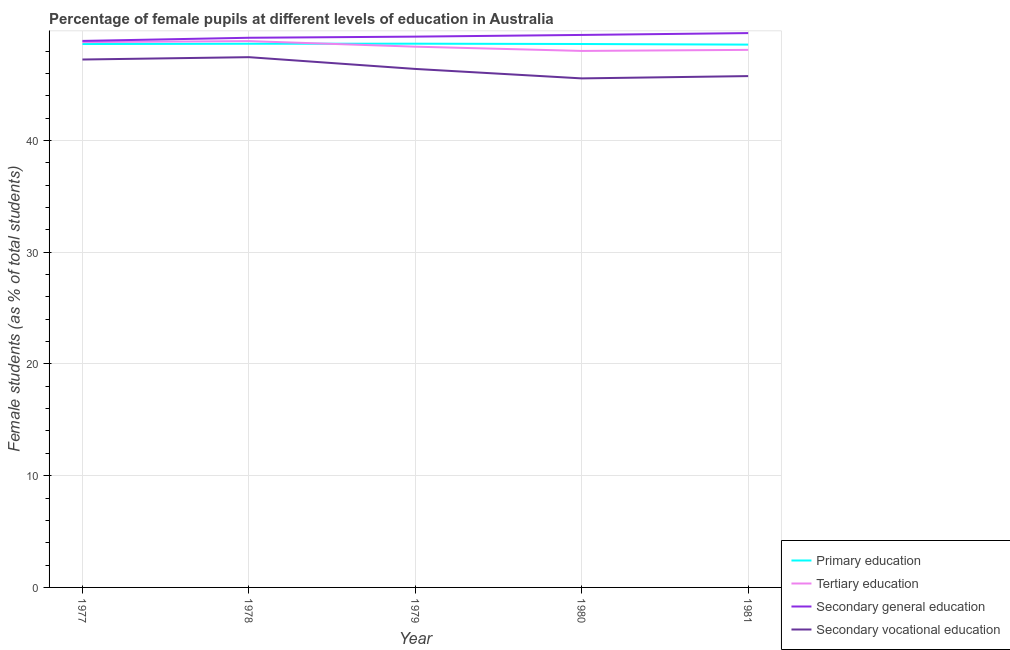Does the line corresponding to percentage of female students in tertiary education intersect with the line corresponding to percentage of female students in secondary education?
Your answer should be very brief. No. What is the percentage of female students in secondary vocational education in 1979?
Offer a terse response. 46.4. Across all years, what is the maximum percentage of female students in secondary education?
Your answer should be very brief. 49.61. Across all years, what is the minimum percentage of female students in secondary education?
Ensure brevity in your answer.  48.91. In which year was the percentage of female students in tertiary education maximum?
Provide a short and direct response. 1978. In which year was the percentage of female students in tertiary education minimum?
Provide a succinct answer. 1980. What is the total percentage of female students in tertiary education in the graph?
Your answer should be compact. 242.19. What is the difference between the percentage of female students in secondary education in 1977 and that in 1979?
Make the answer very short. -0.38. What is the difference between the percentage of female students in primary education in 1978 and the percentage of female students in tertiary education in 1979?
Your response must be concise. 0.26. What is the average percentage of female students in primary education per year?
Make the answer very short. 48.63. In the year 1977, what is the difference between the percentage of female students in tertiary education and percentage of female students in secondary education?
Provide a succinct answer. -0.11. What is the ratio of the percentage of female students in secondary education in 1980 to that in 1981?
Your answer should be very brief. 1. Is the difference between the percentage of female students in primary education in 1977 and 1980 greater than the difference between the percentage of female students in secondary education in 1977 and 1980?
Give a very brief answer. Yes. What is the difference between the highest and the second highest percentage of female students in secondary education?
Provide a succinct answer. 0.17. What is the difference between the highest and the lowest percentage of female students in primary education?
Make the answer very short. 0.08. In how many years, is the percentage of female students in secondary vocational education greater than the average percentage of female students in secondary vocational education taken over all years?
Ensure brevity in your answer.  2. Is it the case that in every year, the sum of the percentage of female students in primary education and percentage of female students in tertiary education is greater than the percentage of female students in secondary education?
Ensure brevity in your answer.  Yes. Does the percentage of female students in secondary education monotonically increase over the years?
Your answer should be compact. Yes. Is the percentage of female students in primary education strictly greater than the percentage of female students in secondary vocational education over the years?
Provide a short and direct response. Yes. Is the percentage of female students in tertiary education strictly less than the percentage of female students in secondary vocational education over the years?
Give a very brief answer. No. What is the difference between two consecutive major ticks on the Y-axis?
Provide a succinct answer. 10. Where does the legend appear in the graph?
Your response must be concise. Bottom right. How are the legend labels stacked?
Keep it short and to the point. Vertical. What is the title of the graph?
Offer a terse response. Percentage of female pupils at different levels of education in Australia. What is the label or title of the Y-axis?
Ensure brevity in your answer.  Female students (as % of total students). What is the Female students (as % of total students) of Primary education in 1977?
Your answer should be very brief. 48.63. What is the Female students (as % of total students) of Tertiary education in 1977?
Your answer should be very brief. 48.8. What is the Female students (as % of total students) in Secondary general education in 1977?
Your response must be concise. 48.91. What is the Female students (as % of total students) in Secondary vocational education in 1977?
Your answer should be compact. 47.24. What is the Female students (as % of total students) of Primary education in 1978?
Your answer should be compact. 48.65. What is the Female students (as % of total students) of Tertiary education in 1978?
Offer a very short reply. 48.89. What is the Female students (as % of total students) in Secondary general education in 1978?
Offer a very short reply. 49.19. What is the Female students (as % of total students) of Secondary vocational education in 1978?
Your answer should be compact. 47.45. What is the Female students (as % of total students) in Primary education in 1979?
Provide a succinct answer. 48.66. What is the Female students (as % of total students) in Tertiary education in 1979?
Provide a short and direct response. 48.39. What is the Female students (as % of total students) in Secondary general education in 1979?
Provide a succinct answer. 49.29. What is the Female students (as % of total students) in Secondary vocational education in 1979?
Provide a succinct answer. 46.4. What is the Female students (as % of total students) of Primary education in 1980?
Offer a very short reply. 48.63. What is the Female students (as % of total students) in Tertiary education in 1980?
Provide a succinct answer. 48.01. What is the Female students (as % of total students) in Secondary general education in 1980?
Give a very brief answer. 49.44. What is the Female students (as % of total students) in Secondary vocational education in 1980?
Your answer should be compact. 45.55. What is the Female students (as % of total students) of Primary education in 1981?
Provide a succinct answer. 48.58. What is the Female students (as % of total students) in Tertiary education in 1981?
Give a very brief answer. 48.1. What is the Female students (as % of total students) in Secondary general education in 1981?
Offer a very short reply. 49.61. What is the Female students (as % of total students) in Secondary vocational education in 1981?
Your response must be concise. 45.76. Across all years, what is the maximum Female students (as % of total students) of Primary education?
Offer a very short reply. 48.66. Across all years, what is the maximum Female students (as % of total students) in Tertiary education?
Give a very brief answer. 48.89. Across all years, what is the maximum Female students (as % of total students) of Secondary general education?
Provide a short and direct response. 49.61. Across all years, what is the maximum Female students (as % of total students) in Secondary vocational education?
Give a very brief answer. 47.45. Across all years, what is the minimum Female students (as % of total students) in Primary education?
Keep it short and to the point. 48.58. Across all years, what is the minimum Female students (as % of total students) in Tertiary education?
Ensure brevity in your answer.  48.01. Across all years, what is the minimum Female students (as % of total students) of Secondary general education?
Offer a terse response. 48.91. Across all years, what is the minimum Female students (as % of total students) of Secondary vocational education?
Give a very brief answer. 45.55. What is the total Female students (as % of total students) of Primary education in the graph?
Provide a succinct answer. 243.14. What is the total Female students (as % of total students) of Tertiary education in the graph?
Give a very brief answer. 242.19. What is the total Female students (as % of total students) in Secondary general education in the graph?
Ensure brevity in your answer.  246.43. What is the total Female students (as % of total students) in Secondary vocational education in the graph?
Provide a succinct answer. 232.4. What is the difference between the Female students (as % of total students) of Primary education in 1977 and that in 1978?
Offer a very short reply. -0.03. What is the difference between the Female students (as % of total students) in Tertiary education in 1977 and that in 1978?
Provide a succinct answer. -0.09. What is the difference between the Female students (as % of total students) in Secondary general education in 1977 and that in 1978?
Make the answer very short. -0.28. What is the difference between the Female students (as % of total students) of Secondary vocational education in 1977 and that in 1978?
Provide a short and direct response. -0.21. What is the difference between the Female students (as % of total students) in Primary education in 1977 and that in 1979?
Your answer should be compact. -0.03. What is the difference between the Female students (as % of total students) in Tertiary education in 1977 and that in 1979?
Make the answer very short. 0.41. What is the difference between the Female students (as % of total students) in Secondary general education in 1977 and that in 1979?
Make the answer very short. -0.38. What is the difference between the Female students (as % of total students) in Secondary vocational education in 1977 and that in 1979?
Make the answer very short. 0.84. What is the difference between the Female students (as % of total students) in Primary education in 1977 and that in 1980?
Offer a terse response. -0. What is the difference between the Female students (as % of total students) of Tertiary education in 1977 and that in 1980?
Your answer should be compact. 0.79. What is the difference between the Female students (as % of total students) of Secondary general education in 1977 and that in 1980?
Offer a terse response. -0.53. What is the difference between the Female students (as % of total students) in Secondary vocational education in 1977 and that in 1980?
Provide a short and direct response. 1.69. What is the difference between the Female students (as % of total students) of Primary education in 1977 and that in 1981?
Give a very brief answer. 0.05. What is the difference between the Female students (as % of total students) of Tertiary education in 1977 and that in 1981?
Keep it short and to the point. 0.7. What is the difference between the Female students (as % of total students) in Secondary general education in 1977 and that in 1981?
Offer a terse response. -0.7. What is the difference between the Female students (as % of total students) in Secondary vocational education in 1977 and that in 1981?
Ensure brevity in your answer.  1.48. What is the difference between the Female students (as % of total students) in Primary education in 1978 and that in 1979?
Give a very brief answer. -0.01. What is the difference between the Female students (as % of total students) in Tertiary education in 1978 and that in 1979?
Your response must be concise. 0.5. What is the difference between the Female students (as % of total students) in Secondary general education in 1978 and that in 1979?
Ensure brevity in your answer.  -0.1. What is the difference between the Female students (as % of total students) in Secondary vocational education in 1978 and that in 1979?
Your answer should be compact. 1.05. What is the difference between the Female students (as % of total students) of Primary education in 1978 and that in 1980?
Make the answer very short. 0.02. What is the difference between the Female students (as % of total students) of Tertiary education in 1978 and that in 1980?
Ensure brevity in your answer.  0.88. What is the difference between the Female students (as % of total students) of Secondary general education in 1978 and that in 1980?
Your response must be concise. -0.25. What is the difference between the Female students (as % of total students) in Secondary vocational education in 1978 and that in 1980?
Keep it short and to the point. 1.9. What is the difference between the Female students (as % of total students) of Primary education in 1978 and that in 1981?
Offer a terse response. 0.08. What is the difference between the Female students (as % of total students) in Tertiary education in 1978 and that in 1981?
Ensure brevity in your answer.  0.79. What is the difference between the Female students (as % of total students) of Secondary general education in 1978 and that in 1981?
Provide a succinct answer. -0.42. What is the difference between the Female students (as % of total students) of Secondary vocational education in 1978 and that in 1981?
Keep it short and to the point. 1.69. What is the difference between the Female students (as % of total students) of Primary education in 1979 and that in 1980?
Offer a terse response. 0.03. What is the difference between the Female students (as % of total students) of Tertiary education in 1979 and that in 1980?
Offer a terse response. 0.38. What is the difference between the Female students (as % of total students) in Secondary general education in 1979 and that in 1980?
Give a very brief answer. -0.15. What is the difference between the Female students (as % of total students) in Secondary vocational education in 1979 and that in 1980?
Your answer should be very brief. 0.85. What is the difference between the Female students (as % of total students) of Primary education in 1979 and that in 1981?
Your answer should be compact. 0.08. What is the difference between the Female students (as % of total students) of Tertiary education in 1979 and that in 1981?
Offer a very short reply. 0.29. What is the difference between the Female students (as % of total students) of Secondary general education in 1979 and that in 1981?
Keep it short and to the point. -0.32. What is the difference between the Female students (as % of total students) in Secondary vocational education in 1979 and that in 1981?
Provide a short and direct response. 0.64. What is the difference between the Female students (as % of total students) of Primary education in 1980 and that in 1981?
Give a very brief answer. 0.05. What is the difference between the Female students (as % of total students) in Tertiary education in 1980 and that in 1981?
Your response must be concise. -0.09. What is the difference between the Female students (as % of total students) in Secondary general education in 1980 and that in 1981?
Make the answer very short. -0.17. What is the difference between the Female students (as % of total students) in Secondary vocational education in 1980 and that in 1981?
Your answer should be compact. -0.21. What is the difference between the Female students (as % of total students) in Primary education in 1977 and the Female students (as % of total students) in Tertiary education in 1978?
Your response must be concise. -0.26. What is the difference between the Female students (as % of total students) in Primary education in 1977 and the Female students (as % of total students) in Secondary general education in 1978?
Make the answer very short. -0.56. What is the difference between the Female students (as % of total students) in Primary education in 1977 and the Female students (as % of total students) in Secondary vocational education in 1978?
Offer a very short reply. 1.18. What is the difference between the Female students (as % of total students) of Tertiary education in 1977 and the Female students (as % of total students) of Secondary general education in 1978?
Give a very brief answer. -0.39. What is the difference between the Female students (as % of total students) of Tertiary education in 1977 and the Female students (as % of total students) of Secondary vocational education in 1978?
Make the answer very short. 1.35. What is the difference between the Female students (as % of total students) of Secondary general education in 1977 and the Female students (as % of total students) of Secondary vocational education in 1978?
Offer a terse response. 1.45. What is the difference between the Female students (as % of total students) of Primary education in 1977 and the Female students (as % of total students) of Tertiary education in 1979?
Keep it short and to the point. 0.24. What is the difference between the Female students (as % of total students) of Primary education in 1977 and the Female students (as % of total students) of Secondary general education in 1979?
Make the answer very short. -0.66. What is the difference between the Female students (as % of total students) in Primary education in 1977 and the Female students (as % of total students) in Secondary vocational education in 1979?
Your answer should be compact. 2.23. What is the difference between the Female students (as % of total students) in Tertiary education in 1977 and the Female students (as % of total students) in Secondary general education in 1979?
Your answer should be compact. -0.49. What is the difference between the Female students (as % of total students) of Tertiary education in 1977 and the Female students (as % of total students) of Secondary vocational education in 1979?
Offer a terse response. 2.4. What is the difference between the Female students (as % of total students) in Secondary general education in 1977 and the Female students (as % of total students) in Secondary vocational education in 1979?
Keep it short and to the point. 2.51. What is the difference between the Female students (as % of total students) in Primary education in 1977 and the Female students (as % of total students) in Tertiary education in 1980?
Offer a very short reply. 0.62. What is the difference between the Female students (as % of total students) of Primary education in 1977 and the Female students (as % of total students) of Secondary general education in 1980?
Your response must be concise. -0.81. What is the difference between the Female students (as % of total students) of Primary education in 1977 and the Female students (as % of total students) of Secondary vocational education in 1980?
Give a very brief answer. 3.07. What is the difference between the Female students (as % of total students) in Tertiary education in 1977 and the Female students (as % of total students) in Secondary general education in 1980?
Your answer should be compact. -0.64. What is the difference between the Female students (as % of total students) of Tertiary education in 1977 and the Female students (as % of total students) of Secondary vocational education in 1980?
Your answer should be very brief. 3.25. What is the difference between the Female students (as % of total students) in Secondary general education in 1977 and the Female students (as % of total students) in Secondary vocational education in 1980?
Keep it short and to the point. 3.35. What is the difference between the Female students (as % of total students) of Primary education in 1977 and the Female students (as % of total students) of Tertiary education in 1981?
Your answer should be very brief. 0.52. What is the difference between the Female students (as % of total students) of Primary education in 1977 and the Female students (as % of total students) of Secondary general education in 1981?
Give a very brief answer. -0.98. What is the difference between the Female students (as % of total students) of Primary education in 1977 and the Female students (as % of total students) of Secondary vocational education in 1981?
Give a very brief answer. 2.87. What is the difference between the Female students (as % of total students) in Tertiary education in 1977 and the Female students (as % of total students) in Secondary general education in 1981?
Provide a succinct answer. -0.81. What is the difference between the Female students (as % of total students) of Tertiary education in 1977 and the Female students (as % of total students) of Secondary vocational education in 1981?
Your answer should be very brief. 3.04. What is the difference between the Female students (as % of total students) of Secondary general education in 1977 and the Female students (as % of total students) of Secondary vocational education in 1981?
Your answer should be very brief. 3.15. What is the difference between the Female students (as % of total students) of Primary education in 1978 and the Female students (as % of total students) of Tertiary education in 1979?
Give a very brief answer. 0.26. What is the difference between the Female students (as % of total students) in Primary education in 1978 and the Female students (as % of total students) in Secondary general education in 1979?
Your response must be concise. -0.64. What is the difference between the Female students (as % of total students) in Primary education in 1978 and the Female students (as % of total students) in Secondary vocational education in 1979?
Your answer should be very brief. 2.25. What is the difference between the Female students (as % of total students) in Tertiary education in 1978 and the Female students (as % of total students) in Secondary general education in 1979?
Make the answer very short. -0.4. What is the difference between the Female students (as % of total students) in Tertiary education in 1978 and the Female students (as % of total students) in Secondary vocational education in 1979?
Ensure brevity in your answer.  2.49. What is the difference between the Female students (as % of total students) in Secondary general education in 1978 and the Female students (as % of total students) in Secondary vocational education in 1979?
Make the answer very short. 2.79. What is the difference between the Female students (as % of total students) of Primary education in 1978 and the Female students (as % of total students) of Tertiary education in 1980?
Offer a terse response. 0.64. What is the difference between the Female students (as % of total students) in Primary education in 1978 and the Female students (as % of total students) in Secondary general education in 1980?
Provide a short and direct response. -0.79. What is the difference between the Female students (as % of total students) of Tertiary education in 1978 and the Female students (as % of total students) of Secondary general education in 1980?
Make the answer very short. -0.55. What is the difference between the Female students (as % of total students) in Tertiary education in 1978 and the Female students (as % of total students) in Secondary vocational education in 1980?
Ensure brevity in your answer.  3.34. What is the difference between the Female students (as % of total students) in Secondary general education in 1978 and the Female students (as % of total students) in Secondary vocational education in 1980?
Ensure brevity in your answer.  3.63. What is the difference between the Female students (as % of total students) in Primary education in 1978 and the Female students (as % of total students) in Tertiary education in 1981?
Offer a very short reply. 0.55. What is the difference between the Female students (as % of total students) of Primary education in 1978 and the Female students (as % of total students) of Secondary general education in 1981?
Provide a succinct answer. -0.95. What is the difference between the Female students (as % of total students) in Primary education in 1978 and the Female students (as % of total students) in Secondary vocational education in 1981?
Your answer should be compact. 2.89. What is the difference between the Female students (as % of total students) in Tertiary education in 1978 and the Female students (as % of total students) in Secondary general education in 1981?
Offer a terse response. -0.72. What is the difference between the Female students (as % of total students) in Tertiary education in 1978 and the Female students (as % of total students) in Secondary vocational education in 1981?
Your answer should be very brief. 3.13. What is the difference between the Female students (as % of total students) in Secondary general education in 1978 and the Female students (as % of total students) in Secondary vocational education in 1981?
Your response must be concise. 3.43. What is the difference between the Female students (as % of total students) of Primary education in 1979 and the Female students (as % of total students) of Tertiary education in 1980?
Your answer should be very brief. 0.65. What is the difference between the Female students (as % of total students) in Primary education in 1979 and the Female students (as % of total students) in Secondary general education in 1980?
Your answer should be compact. -0.78. What is the difference between the Female students (as % of total students) in Primary education in 1979 and the Female students (as % of total students) in Secondary vocational education in 1980?
Your response must be concise. 3.11. What is the difference between the Female students (as % of total students) of Tertiary education in 1979 and the Female students (as % of total students) of Secondary general education in 1980?
Provide a succinct answer. -1.05. What is the difference between the Female students (as % of total students) of Tertiary education in 1979 and the Female students (as % of total students) of Secondary vocational education in 1980?
Ensure brevity in your answer.  2.84. What is the difference between the Female students (as % of total students) in Secondary general education in 1979 and the Female students (as % of total students) in Secondary vocational education in 1980?
Your answer should be very brief. 3.74. What is the difference between the Female students (as % of total students) in Primary education in 1979 and the Female students (as % of total students) in Tertiary education in 1981?
Ensure brevity in your answer.  0.56. What is the difference between the Female students (as % of total students) of Primary education in 1979 and the Female students (as % of total students) of Secondary general education in 1981?
Make the answer very short. -0.95. What is the difference between the Female students (as % of total students) in Primary education in 1979 and the Female students (as % of total students) in Secondary vocational education in 1981?
Your response must be concise. 2.9. What is the difference between the Female students (as % of total students) in Tertiary education in 1979 and the Female students (as % of total students) in Secondary general education in 1981?
Your answer should be very brief. -1.22. What is the difference between the Female students (as % of total students) of Tertiary education in 1979 and the Female students (as % of total students) of Secondary vocational education in 1981?
Keep it short and to the point. 2.63. What is the difference between the Female students (as % of total students) of Secondary general education in 1979 and the Female students (as % of total students) of Secondary vocational education in 1981?
Make the answer very short. 3.53. What is the difference between the Female students (as % of total students) of Primary education in 1980 and the Female students (as % of total students) of Tertiary education in 1981?
Keep it short and to the point. 0.53. What is the difference between the Female students (as % of total students) of Primary education in 1980 and the Female students (as % of total students) of Secondary general education in 1981?
Keep it short and to the point. -0.98. What is the difference between the Female students (as % of total students) in Primary education in 1980 and the Female students (as % of total students) in Secondary vocational education in 1981?
Ensure brevity in your answer.  2.87. What is the difference between the Female students (as % of total students) in Tertiary education in 1980 and the Female students (as % of total students) in Secondary general education in 1981?
Offer a terse response. -1.6. What is the difference between the Female students (as % of total students) in Tertiary education in 1980 and the Female students (as % of total students) in Secondary vocational education in 1981?
Provide a succinct answer. 2.25. What is the difference between the Female students (as % of total students) in Secondary general education in 1980 and the Female students (as % of total students) in Secondary vocational education in 1981?
Your response must be concise. 3.68. What is the average Female students (as % of total students) in Primary education per year?
Offer a terse response. 48.63. What is the average Female students (as % of total students) in Tertiary education per year?
Your answer should be compact. 48.44. What is the average Female students (as % of total students) of Secondary general education per year?
Your answer should be compact. 49.29. What is the average Female students (as % of total students) in Secondary vocational education per year?
Ensure brevity in your answer.  46.48. In the year 1977, what is the difference between the Female students (as % of total students) in Primary education and Female students (as % of total students) in Tertiary education?
Keep it short and to the point. -0.17. In the year 1977, what is the difference between the Female students (as % of total students) in Primary education and Female students (as % of total students) in Secondary general education?
Offer a very short reply. -0.28. In the year 1977, what is the difference between the Female students (as % of total students) in Primary education and Female students (as % of total students) in Secondary vocational education?
Your answer should be compact. 1.39. In the year 1977, what is the difference between the Female students (as % of total students) in Tertiary education and Female students (as % of total students) in Secondary general education?
Your answer should be compact. -0.11. In the year 1977, what is the difference between the Female students (as % of total students) of Tertiary education and Female students (as % of total students) of Secondary vocational education?
Your response must be concise. 1.56. In the year 1977, what is the difference between the Female students (as % of total students) in Secondary general education and Female students (as % of total students) in Secondary vocational education?
Offer a terse response. 1.66. In the year 1978, what is the difference between the Female students (as % of total students) of Primary education and Female students (as % of total students) of Tertiary education?
Provide a succinct answer. -0.24. In the year 1978, what is the difference between the Female students (as % of total students) in Primary education and Female students (as % of total students) in Secondary general education?
Your answer should be very brief. -0.53. In the year 1978, what is the difference between the Female students (as % of total students) in Primary education and Female students (as % of total students) in Secondary vocational education?
Provide a succinct answer. 1.2. In the year 1978, what is the difference between the Female students (as % of total students) of Tertiary education and Female students (as % of total students) of Secondary general education?
Your answer should be compact. -0.3. In the year 1978, what is the difference between the Female students (as % of total students) of Tertiary education and Female students (as % of total students) of Secondary vocational education?
Provide a short and direct response. 1.44. In the year 1978, what is the difference between the Female students (as % of total students) of Secondary general education and Female students (as % of total students) of Secondary vocational education?
Ensure brevity in your answer.  1.74. In the year 1979, what is the difference between the Female students (as % of total students) in Primary education and Female students (as % of total students) in Tertiary education?
Provide a succinct answer. 0.27. In the year 1979, what is the difference between the Female students (as % of total students) of Primary education and Female students (as % of total students) of Secondary general education?
Your response must be concise. -0.63. In the year 1979, what is the difference between the Female students (as % of total students) of Primary education and Female students (as % of total students) of Secondary vocational education?
Provide a succinct answer. 2.26. In the year 1979, what is the difference between the Female students (as % of total students) in Tertiary education and Female students (as % of total students) in Secondary general education?
Your response must be concise. -0.9. In the year 1979, what is the difference between the Female students (as % of total students) of Tertiary education and Female students (as % of total students) of Secondary vocational education?
Ensure brevity in your answer.  1.99. In the year 1979, what is the difference between the Female students (as % of total students) in Secondary general education and Female students (as % of total students) in Secondary vocational education?
Keep it short and to the point. 2.89. In the year 1980, what is the difference between the Female students (as % of total students) of Primary education and Female students (as % of total students) of Tertiary education?
Your answer should be compact. 0.62. In the year 1980, what is the difference between the Female students (as % of total students) in Primary education and Female students (as % of total students) in Secondary general education?
Your answer should be very brief. -0.81. In the year 1980, what is the difference between the Female students (as % of total students) in Primary education and Female students (as % of total students) in Secondary vocational education?
Provide a succinct answer. 3.08. In the year 1980, what is the difference between the Female students (as % of total students) in Tertiary education and Female students (as % of total students) in Secondary general education?
Offer a terse response. -1.43. In the year 1980, what is the difference between the Female students (as % of total students) in Tertiary education and Female students (as % of total students) in Secondary vocational education?
Your answer should be very brief. 2.46. In the year 1980, what is the difference between the Female students (as % of total students) in Secondary general education and Female students (as % of total students) in Secondary vocational education?
Make the answer very short. 3.89. In the year 1981, what is the difference between the Female students (as % of total students) in Primary education and Female students (as % of total students) in Tertiary education?
Your answer should be very brief. 0.47. In the year 1981, what is the difference between the Female students (as % of total students) in Primary education and Female students (as % of total students) in Secondary general education?
Ensure brevity in your answer.  -1.03. In the year 1981, what is the difference between the Female students (as % of total students) of Primary education and Female students (as % of total students) of Secondary vocational education?
Offer a very short reply. 2.82. In the year 1981, what is the difference between the Female students (as % of total students) in Tertiary education and Female students (as % of total students) in Secondary general education?
Offer a terse response. -1.5. In the year 1981, what is the difference between the Female students (as % of total students) in Tertiary education and Female students (as % of total students) in Secondary vocational education?
Your answer should be compact. 2.35. In the year 1981, what is the difference between the Female students (as % of total students) in Secondary general education and Female students (as % of total students) in Secondary vocational education?
Offer a very short reply. 3.85. What is the ratio of the Female students (as % of total students) in Primary education in 1977 to that in 1978?
Offer a terse response. 1. What is the ratio of the Female students (as % of total students) of Tertiary education in 1977 to that in 1978?
Offer a very short reply. 1. What is the ratio of the Female students (as % of total students) of Secondary vocational education in 1977 to that in 1978?
Your response must be concise. 1. What is the ratio of the Female students (as % of total students) in Primary education in 1977 to that in 1979?
Give a very brief answer. 1. What is the ratio of the Female students (as % of total students) of Tertiary education in 1977 to that in 1979?
Ensure brevity in your answer.  1.01. What is the ratio of the Female students (as % of total students) in Secondary vocational education in 1977 to that in 1979?
Provide a short and direct response. 1.02. What is the ratio of the Female students (as % of total students) in Primary education in 1977 to that in 1980?
Make the answer very short. 1. What is the ratio of the Female students (as % of total students) in Tertiary education in 1977 to that in 1980?
Keep it short and to the point. 1.02. What is the ratio of the Female students (as % of total students) in Secondary vocational education in 1977 to that in 1980?
Keep it short and to the point. 1.04. What is the ratio of the Female students (as % of total students) in Tertiary education in 1977 to that in 1981?
Give a very brief answer. 1.01. What is the ratio of the Female students (as % of total students) of Secondary general education in 1977 to that in 1981?
Keep it short and to the point. 0.99. What is the ratio of the Female students (as % of total students) in Secondary vocational education in 1977 to that in 1981?
Your answer should be very brief. 1.03. What is the ratio of the Female students (as % of total students) of Primary education in 1978 to that in 1979?
Give a very brief answer. 1. What is the ratio of the Female students (as % of total students) in Tertiary education in 1978 to that in 1979?
Your response must be concise. 1.01. What is the ratio of the Female students (as % of total students) in Secondary general education in 1978 to that in 1979?
Offer a terse response. 1. What is the ratio of the Female students (as % of total students) in Secondary vocational education in 1978 to that in 1979?
Give a very brief answer. 1.02. What is the ratio of the Female students (as % of total students) in Primary education in 1978 to that in 1980?
Provide a succinct answer. 1. What is the ratio of the Female students (as % of total students) of Tertiary education in 1978 to that in 1980?
Offer a very short reply. 1.02. What is the ratio of the Female students (as % of total students) in Secondary general education in 1978 to that in 1980?
Provide a succinct answer. 0.99. What is the ratio of the Female students (as % of total students) in Secondary vocational education in 1978 to that in 1980?
Provide a succinct answer. 1.04. What is the ratio of the Female students (as % of total students) of Tertiary education in 1978 to that in 1981?
Provide a short and direct response. 1.02. What is the ratio of the Female students (as % of total students) in Tertiary education in 1979 to that in 1980?
Provide a short and direct response. 1.01. What is the ratio of the Female students (as % of total students) in Secondary vocational education in 1979 to that in 1980?
Offer a terse response. 1.02. What is the ratio of the Female students (as % of total students) of Primary education in 1979 to that in 1981?
Provide a short and direct response. 1. What is the ratio of the Female students (as % of total students) of Tertiary education in 1979 to that in 1981?
Your answer should be compact. 1.01. What is the ratio of the Female students (as % of total students) in Secondary general education in 1979 to that in 1981?
Offer a terse response. 0.99. What is the ratio of the Female students (as % of total students) in Tertiary education in 1980 to that in 1981?
Keep it short and to the point. 1. What is the ratio of the Female students (as % of total students) of Secondary general education in 1980 to that in 1981?
Your answer should be very brief. 1. What is the ratio of the Female students (as % of total students) in Secondary vocational education in 1980 to that in 1981?
Your response must be concise. 1. What is the difference between the highest and the second highest Female students (as % of total students) of Primary education?
Your response must be concise. 0.01. What is the difference between the highest and the second highest Female students (as % of total students) in Tertiary education?
Keep it short and to the point. 0.09. What is the difference between the highest and the second highest Female students (as % of total students) of Secondary general education?
Ensure brevity in your answer.  0.17. What is the difference between the highest and the second highest Female students (as % of total students) in Secondary vocational education?
Give a very brief answer. 0.21. What is the difference between the highest and the lowest Female students (as % of total students) of Primary education?
Your answer should be very brief. 0.08. What is the difference between the highest and the lowest Female students (as % of total students) of Tertiary education?
Ensure brevity in your answer.  0.88. What is the difference between the highest and the lowest Female students (as % of total students) in Secondary general education?
Offer a very short reply. 0.7. What is the difference between the highest and the lowest Female students (as % of total students) in Secondary vocational education?
Offer a very short reply. 1.9. 